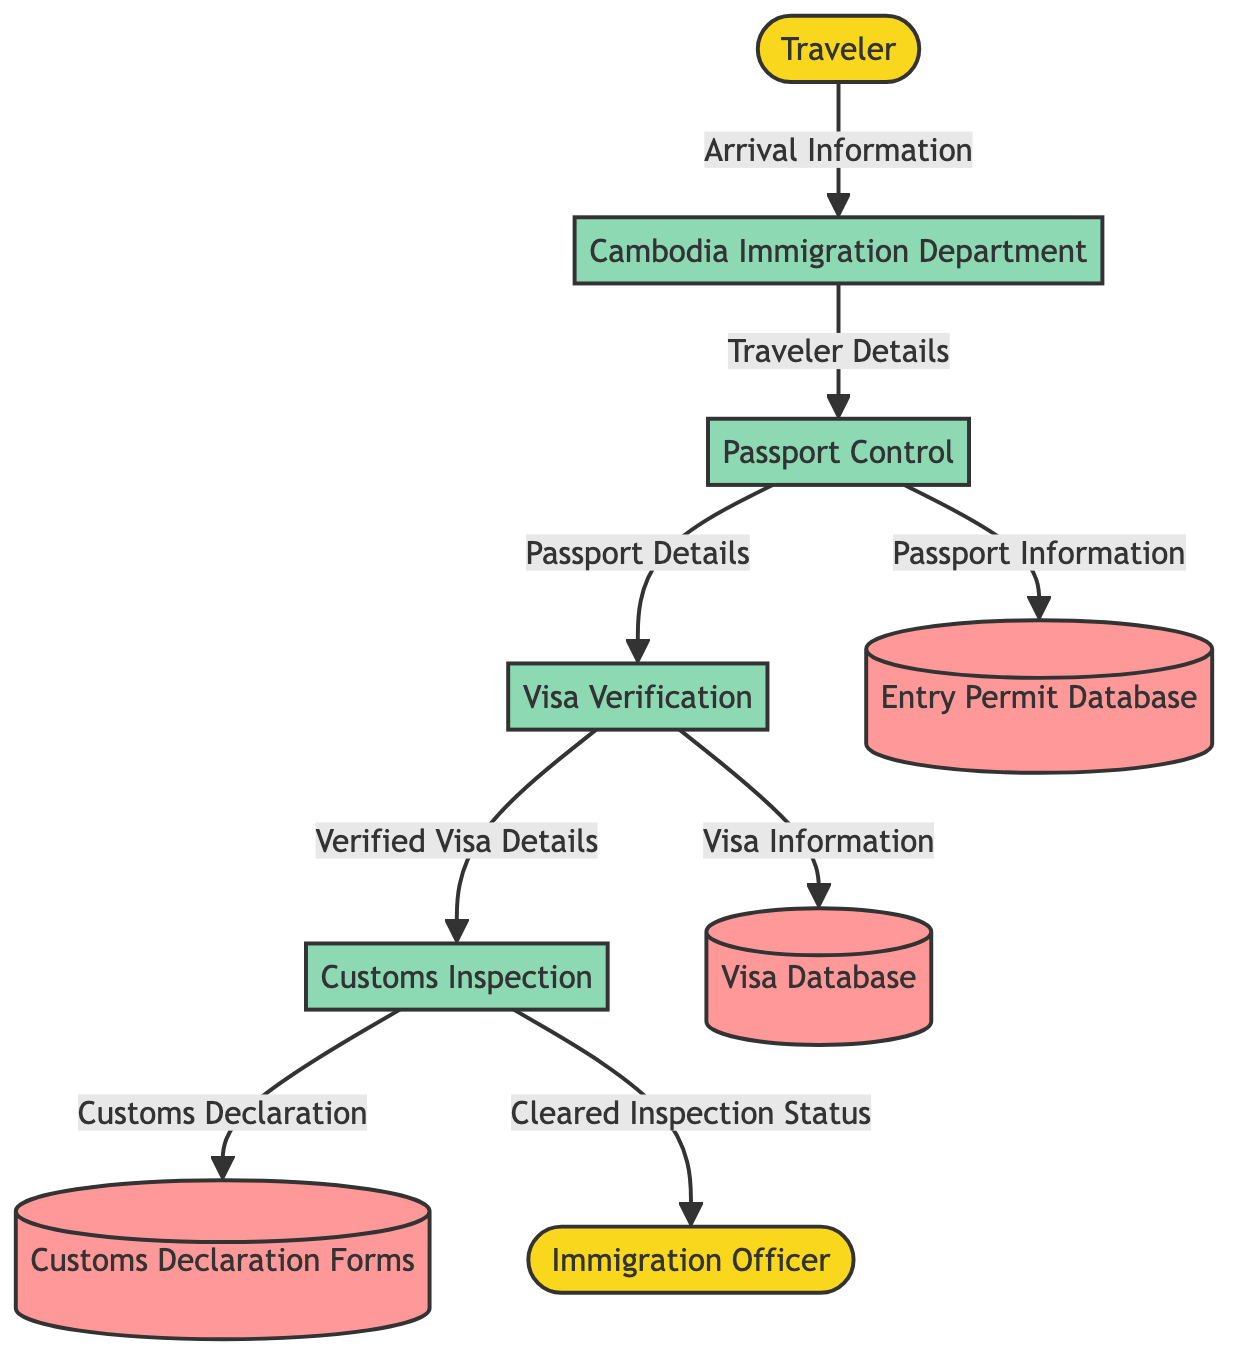What is the total number of processes in the diagram? The diagram lists four processes: Cambodia Immigration Department, Passport Control, Visa Verification, and Customs Inspection. Therefore, by counting these entities, we find that the total number is four.
Answer: 4 Which entity initiates the process by providing Arrival Information? The Traveler is the entity that provides Arrival Information to the Cambodia Immigration Department in the flow of the diagram. Hence, the answer identifies the Traveler as the initiator.
Answer: Traveler What type of data flows from Passport Control to the Entry Permit Database? The data flow from Passport Control to the Entry Permit Database consists of Passport Information, as specified in the diagram. This straightforward relationship clarifies the type of data being transferred.
Answer: Passport Information How many data stores are present in the diagram? The diagram contains three data stores: Entry Permit Database, Visa Database, and Customs Declaration Forms. By counting these data stores, we determine that there are three in total.
Answer: 3 What occurs after Visa Verification that is sent to Customs Inspection? After Visa Verification is processed, the Verified Visa Details are sent to Customs Inspection, as indicated in the flow of the diagram. This shows the distinct data input to a subsequent process.
Answer: Verified Visa Details Which external entity receives Cleared Inspection Status? The Immigration Officer receives the Cleared Inspection Status from the Customs Inspection process, demonstrating a direct communication line to an external entity.
Answer: Immigration Officer What is the relationship between Passport Control and Visa Verification? Passport Control sends Passport Details to Visa Verification, indicating that Passport Control acts as a contributor of information essential for the verification of visa status.
Answer: Passport Details What data follows the Customs Inspection process? The Customs Declaration is the data that flows from Customs Inspection, representing the output that is likely used for reporting or compliance purposes.
Answer: Customs Declaration What type of information is stored in the Visa Database? The Visa Information is the specific type of information that is stored in the Visa Database, as expressed in the flow between Visa Verification and the database.
Answer: Visa Information 